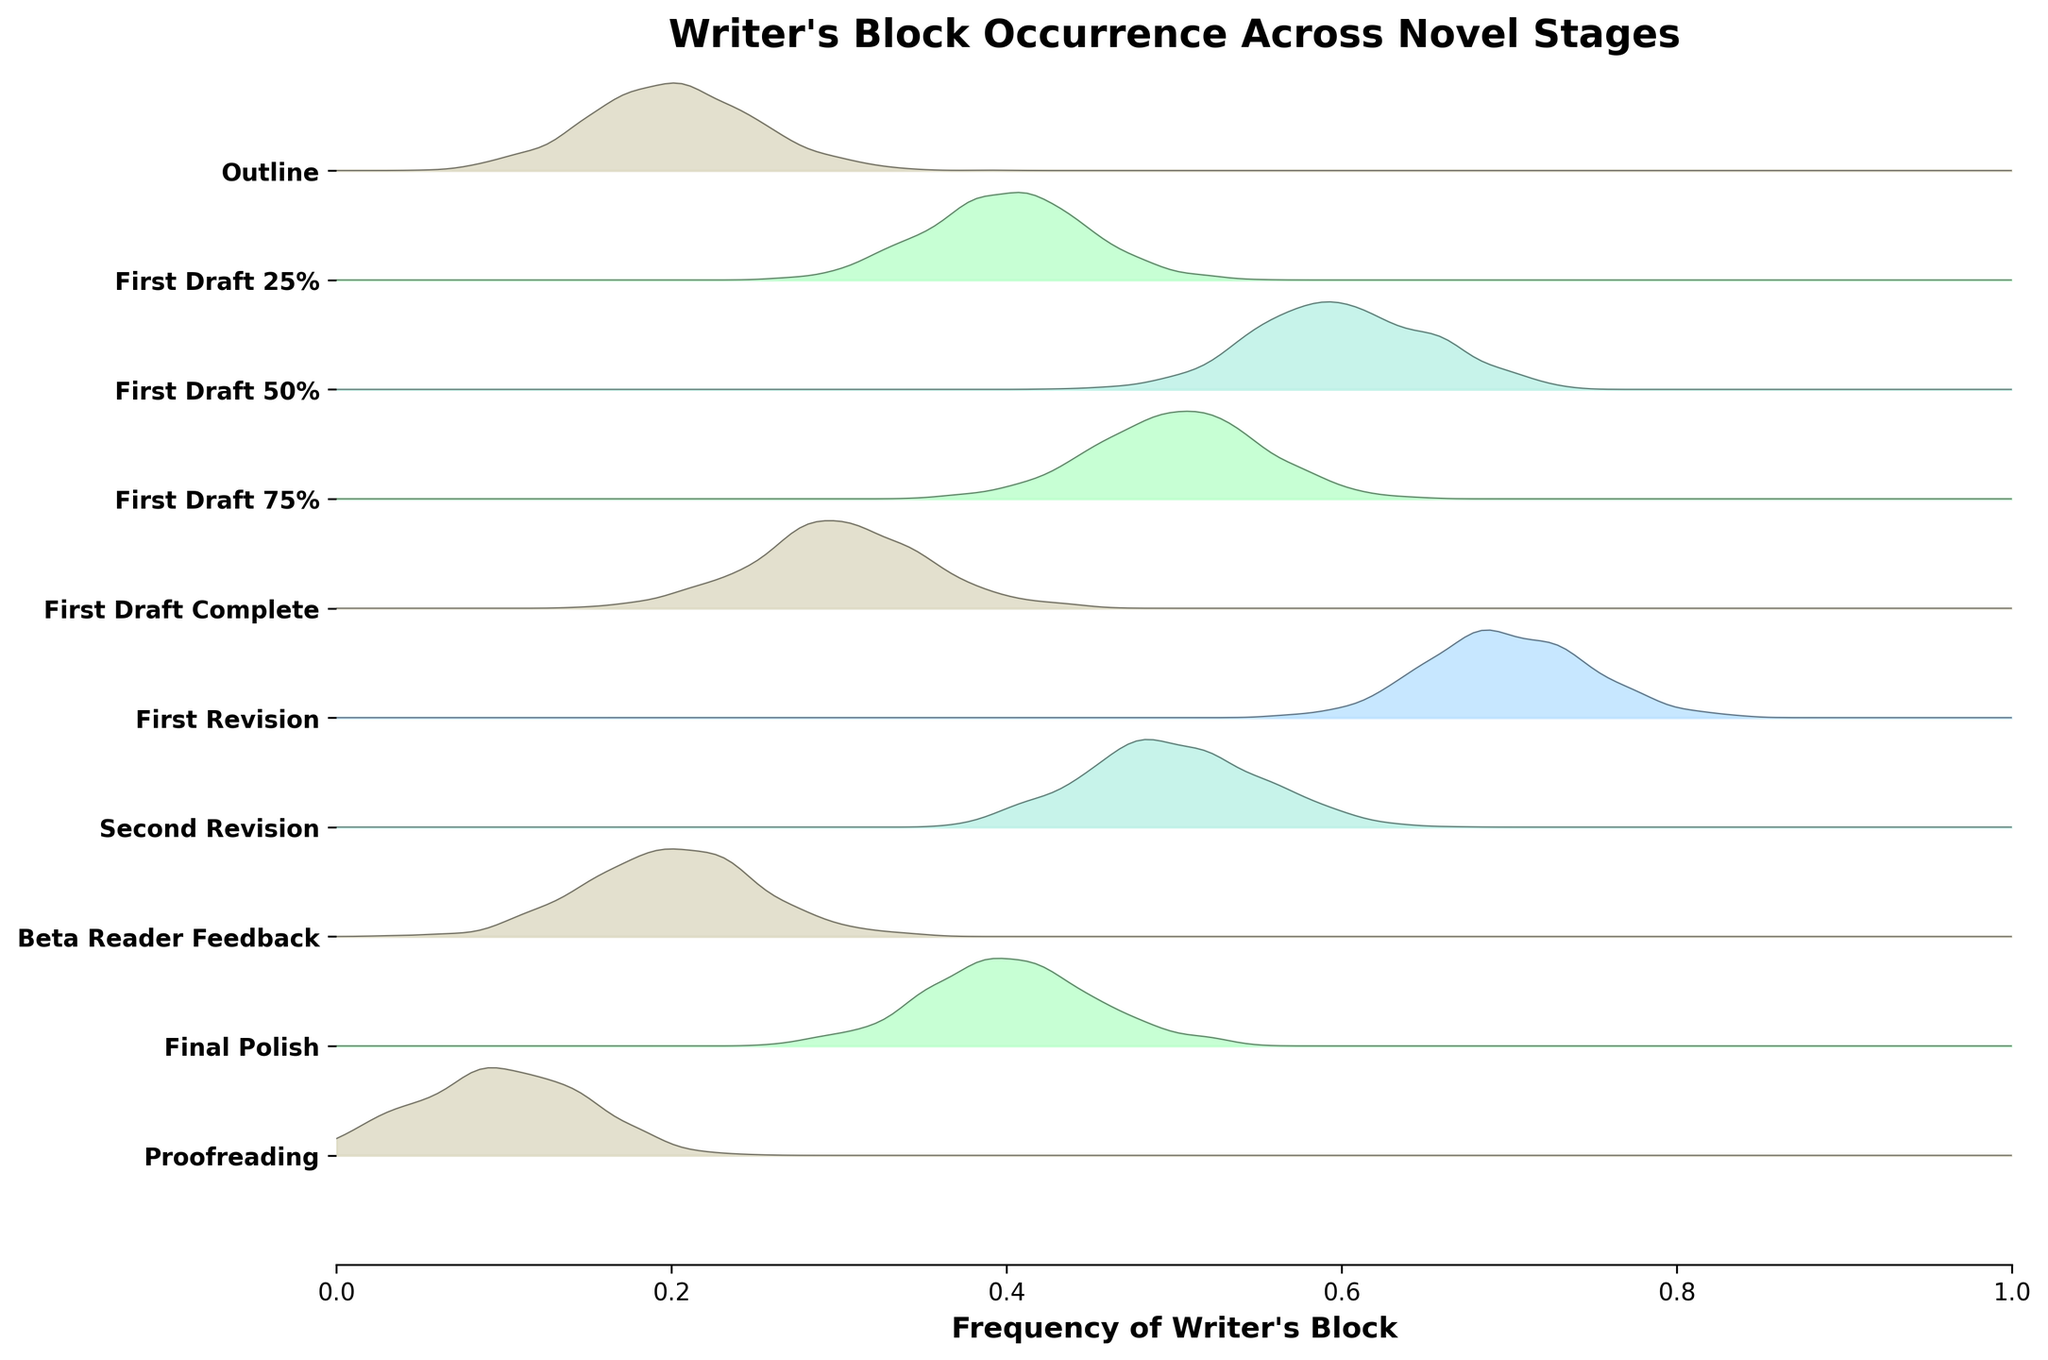What is the title of the figure? The title of the figure is displayed at the top.
Answer: Writer's Block Occurrence Across Novel Stages What is the frequency of writer's block during the 'First Draft 50%' stage? The frequency for each stage is represented by the center of the ridgeline distribution. 'First Draft 50%' is one of the higher frequencies situated around 0.6.
Answer: 0.6 Which stage has the highest intensity of writer's block? The intensity of each stage is indicated by the color gradient, with higher intensities appearing darker or more vibrant. The 'First Revision' stage has the most intense color.
Answer: First Revision During which stage is the frequency of writer's block at its peak? The frequency is observed by the height of the ridgelines, with the highest peak indicating the maximum frequency. The 'First Revision' stage has the highest peak.
Answer: First Revision What is the range of frequency values on the x-axis? The x-axis labels range from 0 to 1.
Answer: 0 to 1 How many stages are represented in the plot? Count the number of unique stages displayed on the y-axis ticks.
Answer: 10 Is the frequency of writer's block lower in the 'Proofreading' stage compared to the 'First Draft Complete' stage? Compare the heights of the ridgeline peaks for both stages. 'Proofreading' has a lower peak frequency than 'First Draft Complete'.
Answer: Yes Which stages have a writer's block intensity of 1 based on color coding? Identify stages corresponding to the lightest color. 'Outline', 'First Draft Complete', 'Beta Reader Feedback', and 'Proofreading' all have this color.
Answer: Outline, First Draft Complete, Beta Reader Feedback, Proofreading Compare the writer's block frequencies between 'First Draft 75%' and 'Second Revision'. Which one is higher? Compare the heights of the ridgelines for both stages. 'First Draft 75%' has a higher peak than 'Second Revision'.
Answer: First Draft 75% What is the difference in frequency between the 'First Draft 50%' and 'First Draft Complete' stages? Subtract the frequency of 'First Draft Complete' (0.3) from 'First Draft 50%' (0.6).
Answer: 0.3 